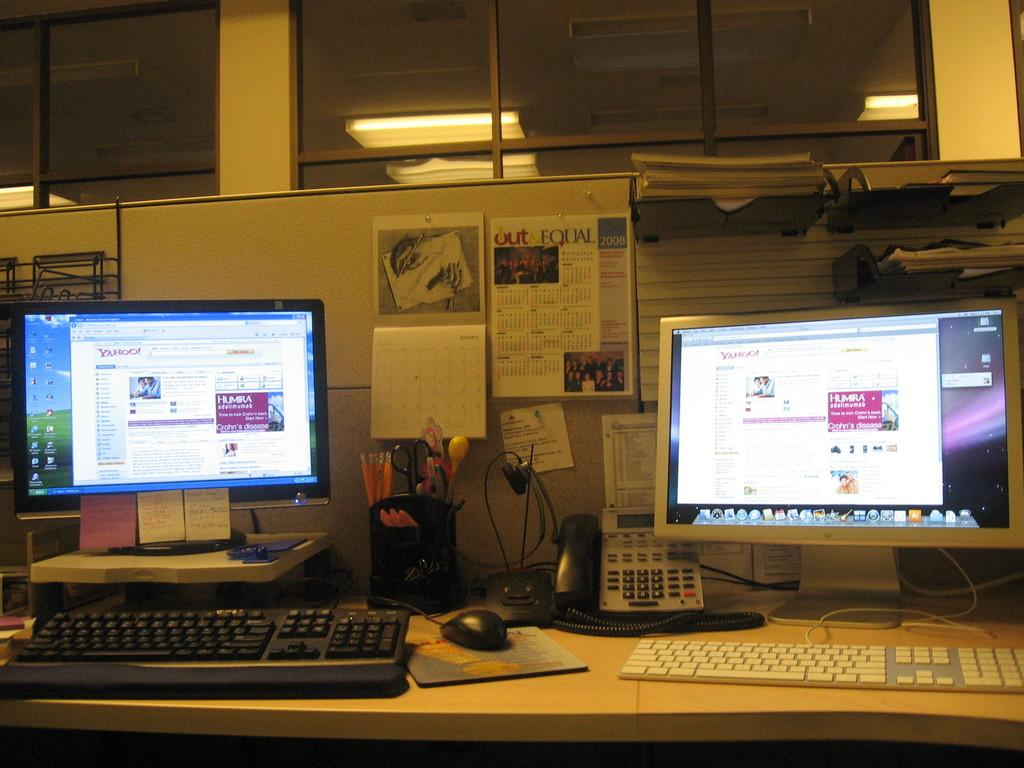<image>
Render a clear and concise summary of the photo. Two computer's sit on top of an office desk  with a 2008 calender in the background called Out and Equal 